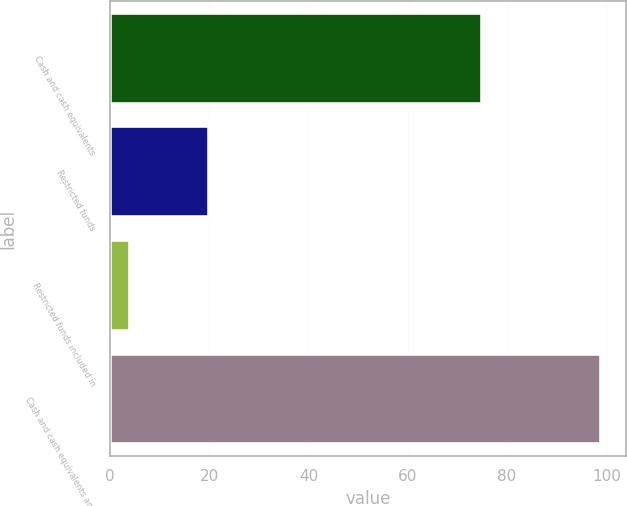<chart> <loc_0><loc_0><loc_500><loc_500><bar_chart><fcel>Cash and cash equivalents<fcel>Restricted funds<fcel>Restricted funds included in<fcel>Cash and cash equivalents and<nl><fcel>75<fcel>20<fcel>4<fcel>99<nl></chart> 